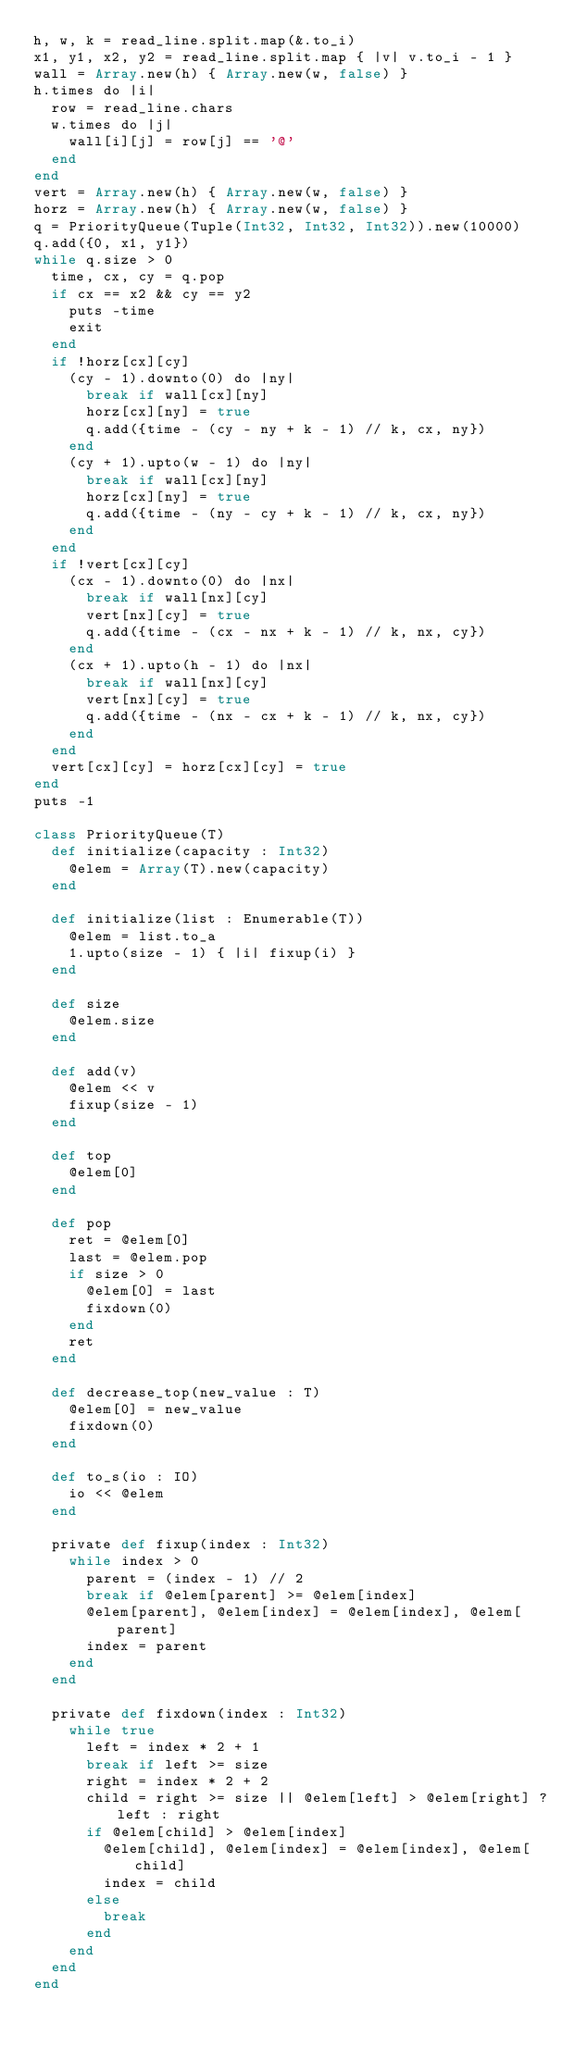<code> <loc_0><loc_0><loc_500><loc_500><_Crystal_>h, w, k = read_line.split.map(&.to_i)
x1, y1, x2, y2 = read_line.split.map { |v| v.to_i - 1 }
wall = Array.new(h) { Array.new(w, false) }
h.times do |i|
  row = read_line.chars
  w.times do |j|
    wall[i][j] = row[j] == '@'
  end
end
vert = Array.new(h) { Array.new(w, false) }
horz = Array.new(h) { Array.new(w, false) }
q = PriorityQueue(Tuple(Int32, Int32, Int32)).new(10000)
q.add({0, x1, y1})
while q.size > 0
  time, cx, cy = q.pop
  if cx == x2 && cy == y2
    puts -time
    exit
  end
  if !horz[cx][cy]
    (cy - 1).downto(0) do |ny|
      break if wall[cx][ny]
      horz[cx][ny] = true
      q.add({time - (cy - ny + k - 1) // k, cx, ny})
    end
    (cy + 1).upto(w - 1) do |ny|
      break if wall[cx][ny]
      horz[cx][ny] = true
      q.add({time - (ny - cy + k - 1) // k, cx, ny})
    end
  end
  if !vert[cx][cy]
    (cx - 1).downto(0) do |nx|
      break if wall[nx][cy]
      vert[nx][cy] = true
      q.add({time - (cx - nx + k - 1) // k, nx, cy})
    end
    (cx + 1).upto(h - 1) do |nx|
      break if wall[nx][cy]
      vert[nx][cy] = true
      q.add({time - (nx - cx + k - 1) // k, nx, cy})
    end
  end
  vert[cx][cy] = horz[cx][cy] = true
end
puts -1

class PriorityQueue(T)
  def initialize(capacity : Int32)
    @elem = Array(T).new(capacity)
  end

  def initialize(list : Enumerable(T))
    @elem = list.to_a
    1.upto(size - 1) { |i| fixup(i) }
  end

  def size
    @elem.size
  end

  def add(v)
    @elem << v
    fixup(size - 1)
  end

  def top
    @elem[0]
  end

  def pop
    ret = @elem[0]
    last = @elem.pop
    if size > 0
      @elem[0] = last
      fixdown(0)
    end
    ret
  end

  def decrease_top(new_value : T)
    @elem[0] = new_value
    fixdown(0)
  end

  def to_s(io : IO)
    io << @elem
  end

  private def fixup(index : Int32)
    while index > 0
      parent = (index - 1) // 2
      break if @elem[parent] >= @elem[index]
      @elem[parent], @elem[index] = @elem[index], @elem[parent]
      index = parent
    end
  end

  private def fixdown(index : Int32)
    while true
      left = index * 2 + 1
      break if left >= size
      right = index * 2 + 2
      child = right >= size || @elem[left] > @elem[right] ? left : right
      if @elem[child] > @elem[index]
        @elem[child], @elem[index] = @elem[index], @elem[child]
        index = child
      else
        break
      end
    end
  end
end
</code> 